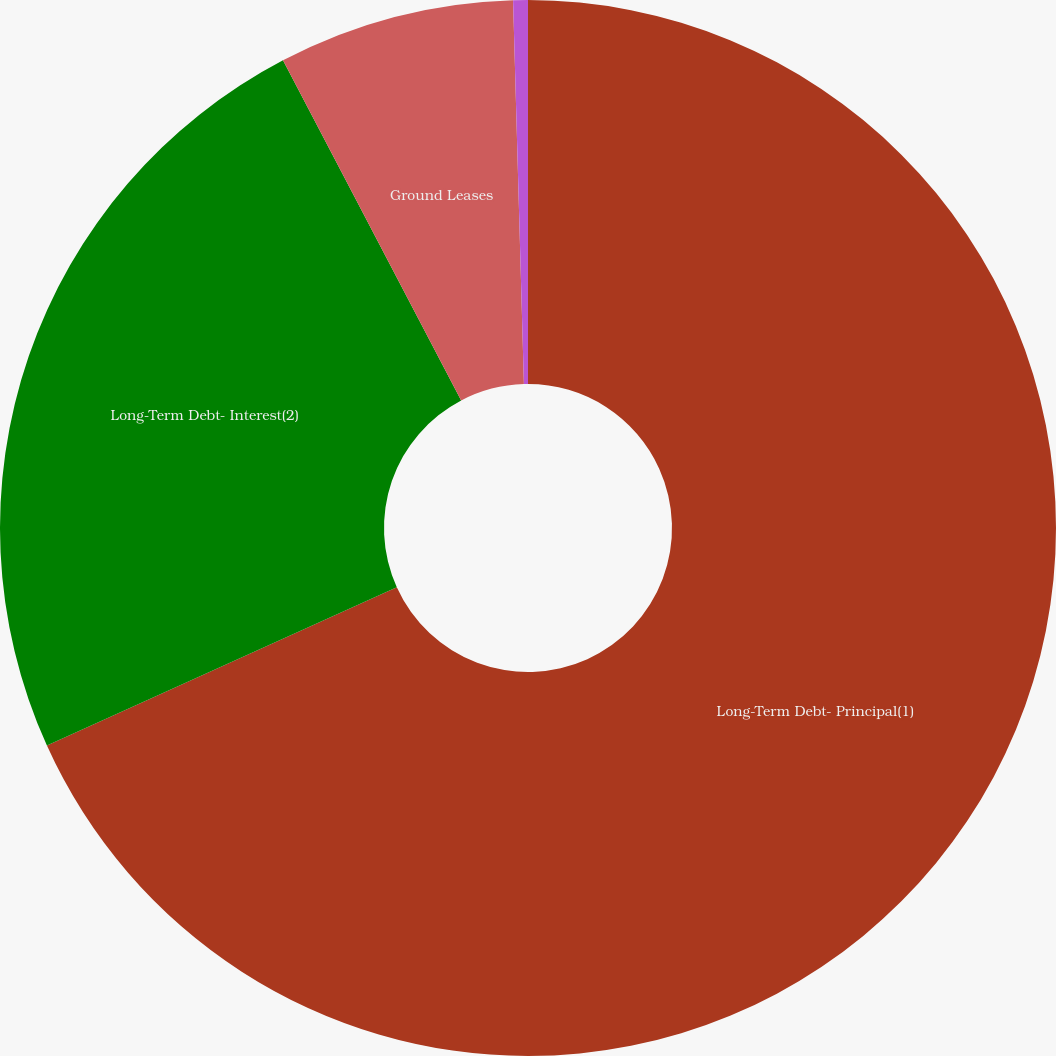<chart> <loc_0><loc_0><loc_500><loc_500><pie_chart><fcel>Long-Term Debt- Principal(1)<fcel>Long-Term Debt- Interest(2)<fcel>Ground Leases<fcel>Retail Store Leases<nl><fcel>68.24%<fcel>24.08%<fcel>7.23%<fcel>0.45%<nl></chart> 